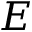Convert formula to latex. <formula><loc_0><loc_0><loc_500><loc_500>E</formula> 